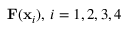<formula> <loc_0><loc_0><loc_500><loc_500>F ( x _ { i } ) , \, i = 1 , 2 , 3 , 4</formula> 